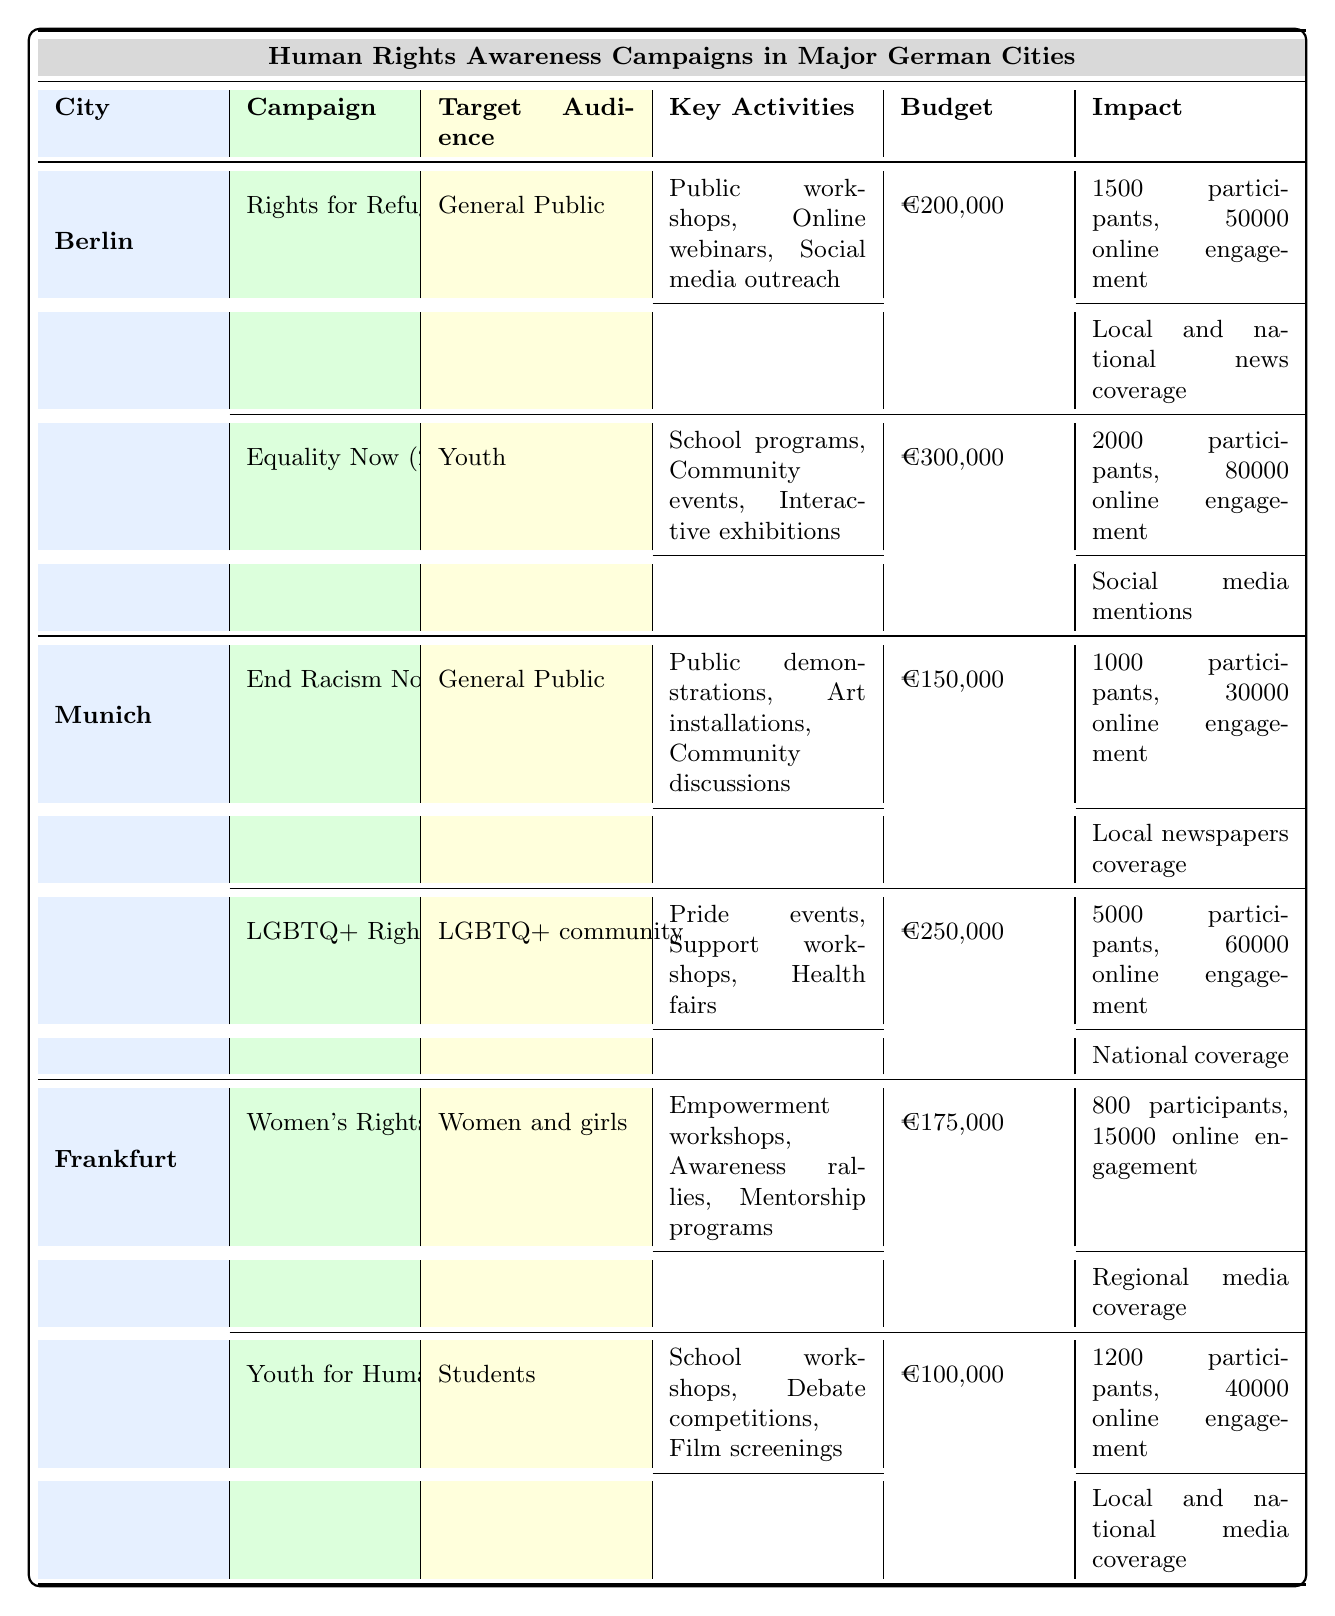What is the budget for the "Equality Now" campaign? The budget for the "Equality Now" campaign, which is listed under the Berlin section for the year 2023, is €300,000.
Answer: €300,000 How many participants attended the "End Racism Now" campaign? According to the table, the "End Racism Now" campaign, held in Munich in 2022, had 1000 participants.
Answer: 1000 Which campaign had the highest online engagement? By comparing the online engagement metrics, the "Equality Now" campaign in Berlin had 80,000 online engagements, which is the highest among all campaigns listed.
Answer: Equality Now Is there any campaign targeting women in Frankfurt? Yes, the "Women's Rights Initiative" campaign in Frankfurt specifically targets women and girls, as indicated in the Target Audience column.
Answer: Yes What is the total budget spent on human rights campaigns in Munich? To find the total budget for Munich, sum the budgets of both campaigns: "End Racism Now" (€150,000) + "LGBTQ+ Rights Awareness" (€250,000) = €400,000.
Answer: €400,000 Which city's campaigns had the highest average number of participants? Calculate the average participants for each city: Berlin (1500 + 2000) / 2 = 1750; Munich (1000 + 5000) / 2 = 3000; Frankfurt (800 + 1200) / 2 = 1000. Munich has the highest average at 3000.
Answer: Munich Did "Youth for Human Rights" receive more media coverage than "LGBTQ+ Rights Awareness"? Based on the table, "Youth for Human Rights" received coverage by both local and national media, while "LGBTQ+ Rights Awareness" had national coverage. Therefore, the coverage type is not comparable as they are both extensive but different types.
Answer: No What percentage of participants in the “Rights for Refugees” campaign engaged online? To find the percentage of online engagement: (50,000 online engagements / 1500 participants) * 100 = 3333.33%. This shows a high level of online engagement compared to the number of participants.
Answer: 3333.33% Which campaign is focused on the LGBTQ+ community? The "LGBTQ+ Rights Awareness" campaign, which took place in 2023 in Munich, specifically targets the LGBTQ+ community as its audience.
Answer: LGBTQ+ Rights Awareness 